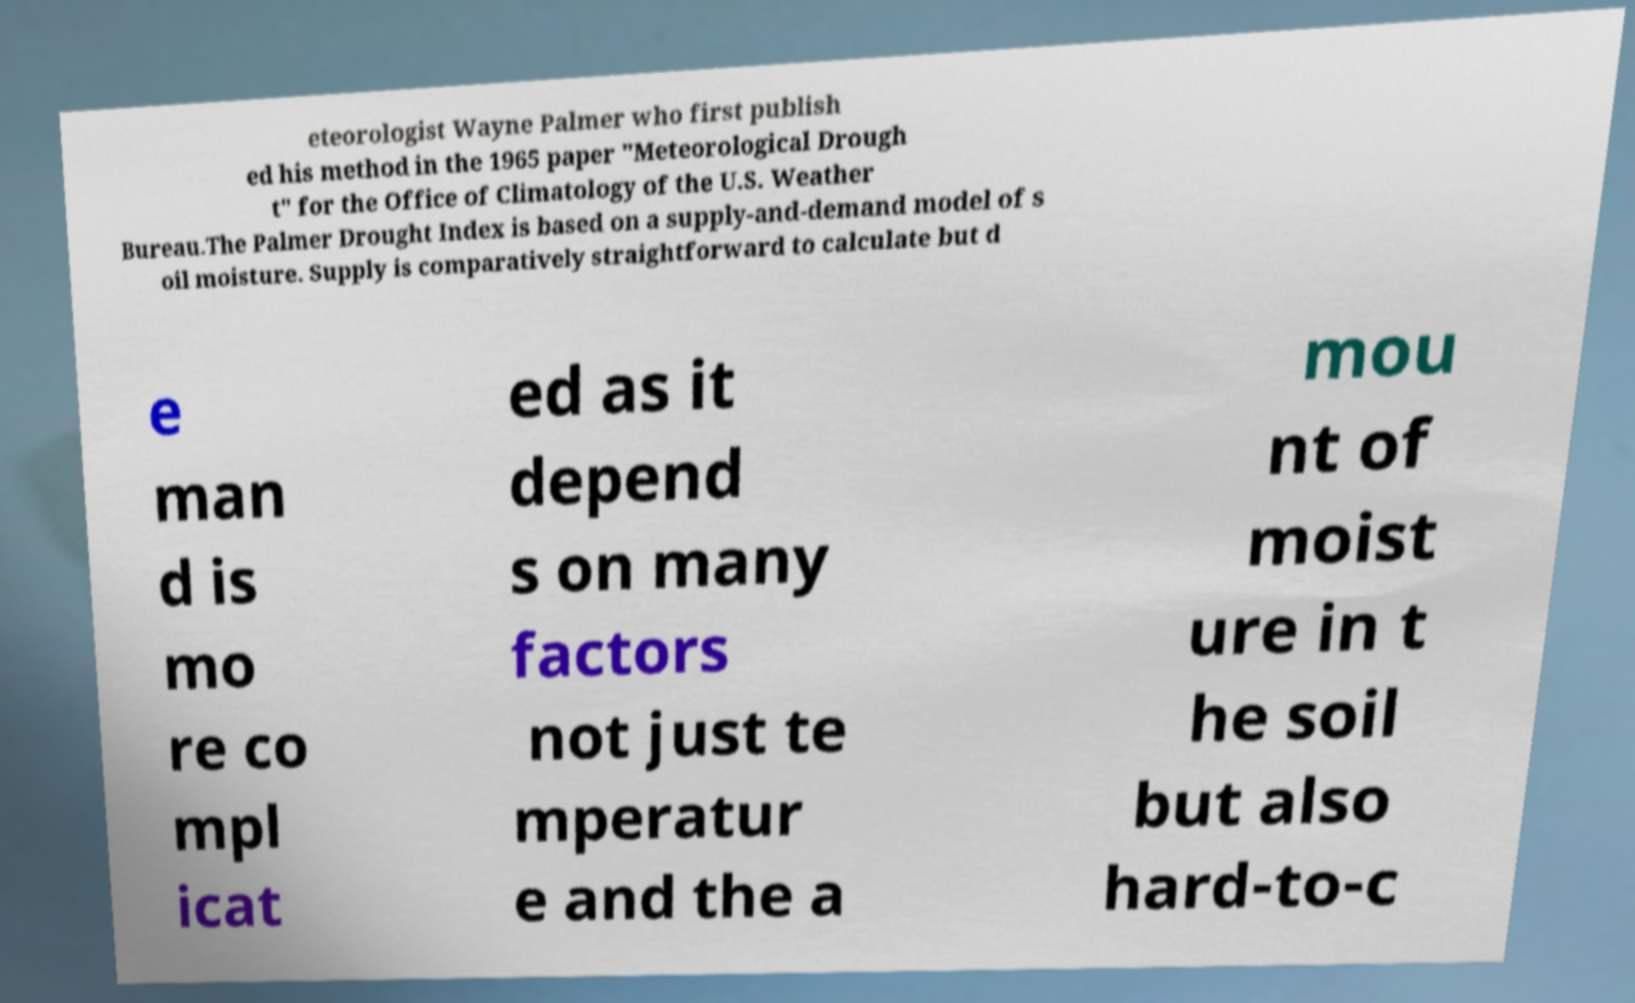Can you accurately transcribe the text from the provided image for me? eteorologist Wayne Palmer who first publish ed his method in the 1965 paper "Meteorological Drough t" for the Office of Climatology of the U.S. Weather Bureau.The Palmer Drought Index is based on a supply-and-demand model of s oil moisture. Supply is comparatively straightforward to calculate but d e man d is mo re co mpl icat ed as it depend s on many factors not just te mperatur e and the a mou nt of moist ure in t he soil but also hard-to-c 